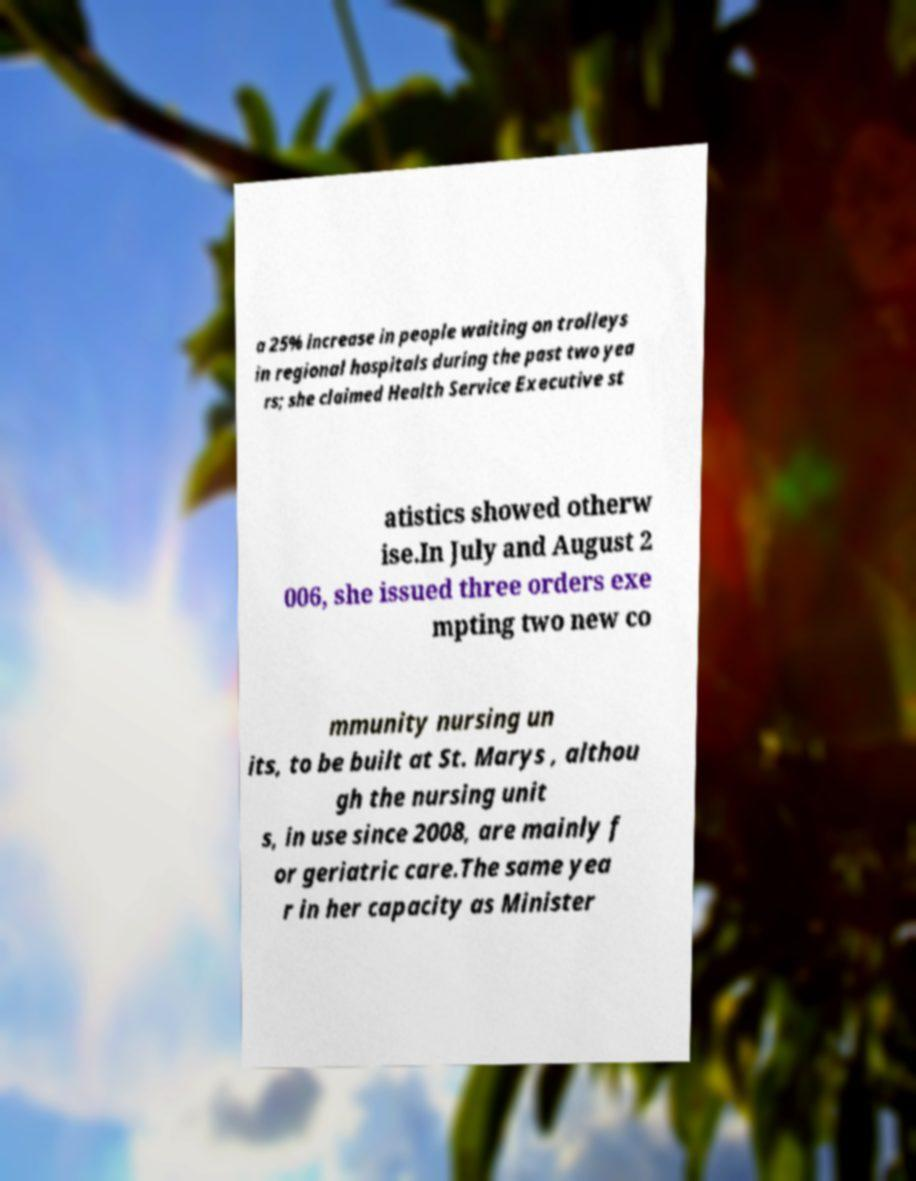Could you assist in decoding the text presented in this image and type it out clearly? a 25% increase in people waiting on trolleys in regional hospitals during the past two yea rs; she claimed Health Service Executive st atistics showed otherw ise.In July and August 2 006, she issued three orders exe mpting two new co mmunity nursing un its, to be built at St. Marys , althou gh the nursing unit s, in use since 2008, are mainly f or geriatric care.The same yea r in her capacity as Minister 